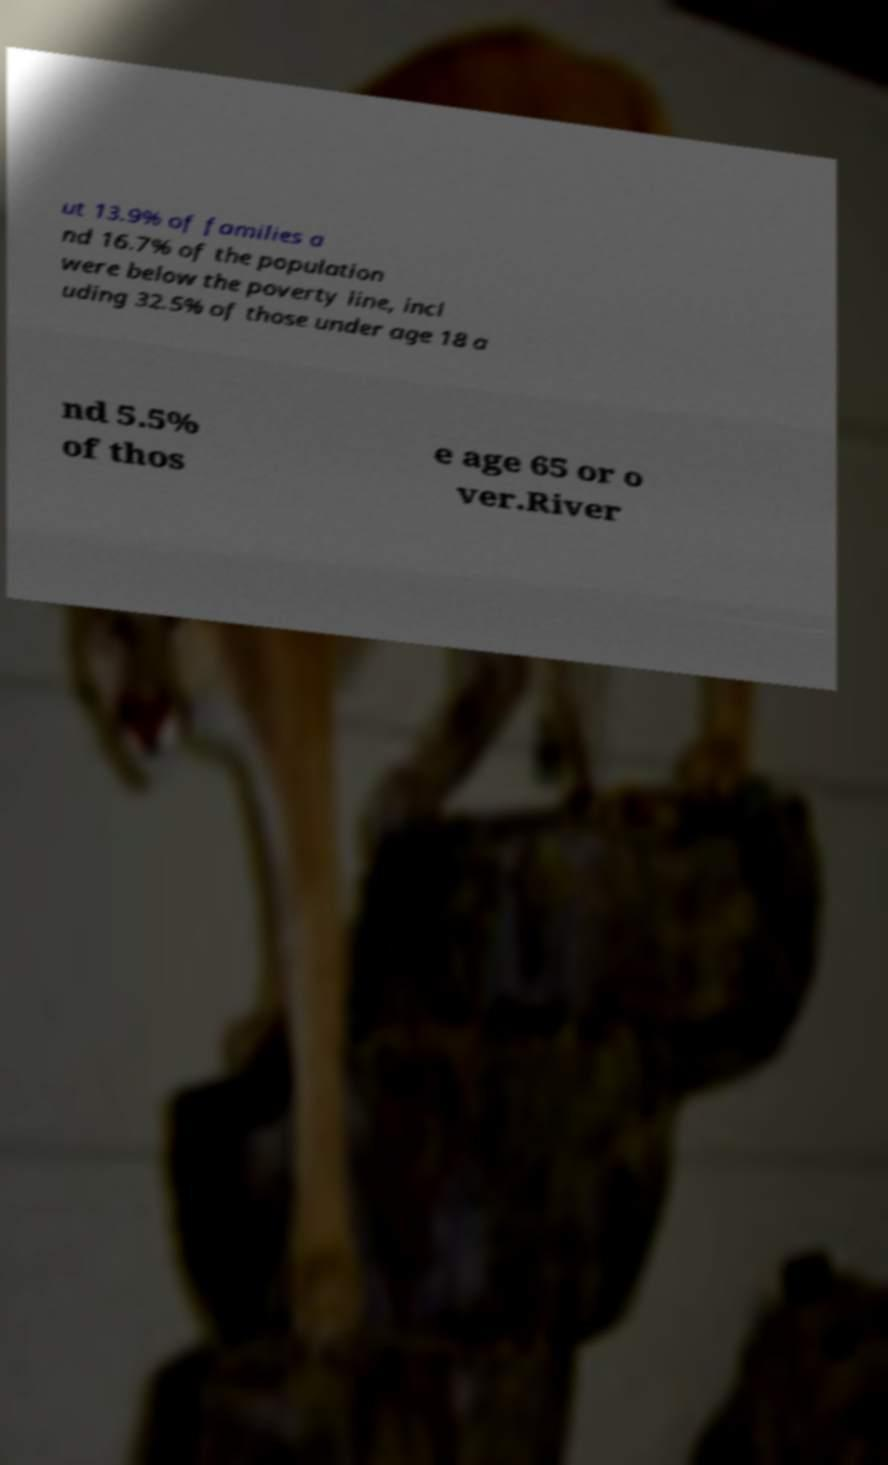For documentation purposes, I need the text within this image transcribed. Could you provide that? ut 13.9% of families a nd 16.7% of the population were below the poverty line, incl uding 32.5% of those under age 18 a nd 5.5% of thos e age 65 or o ver.River 